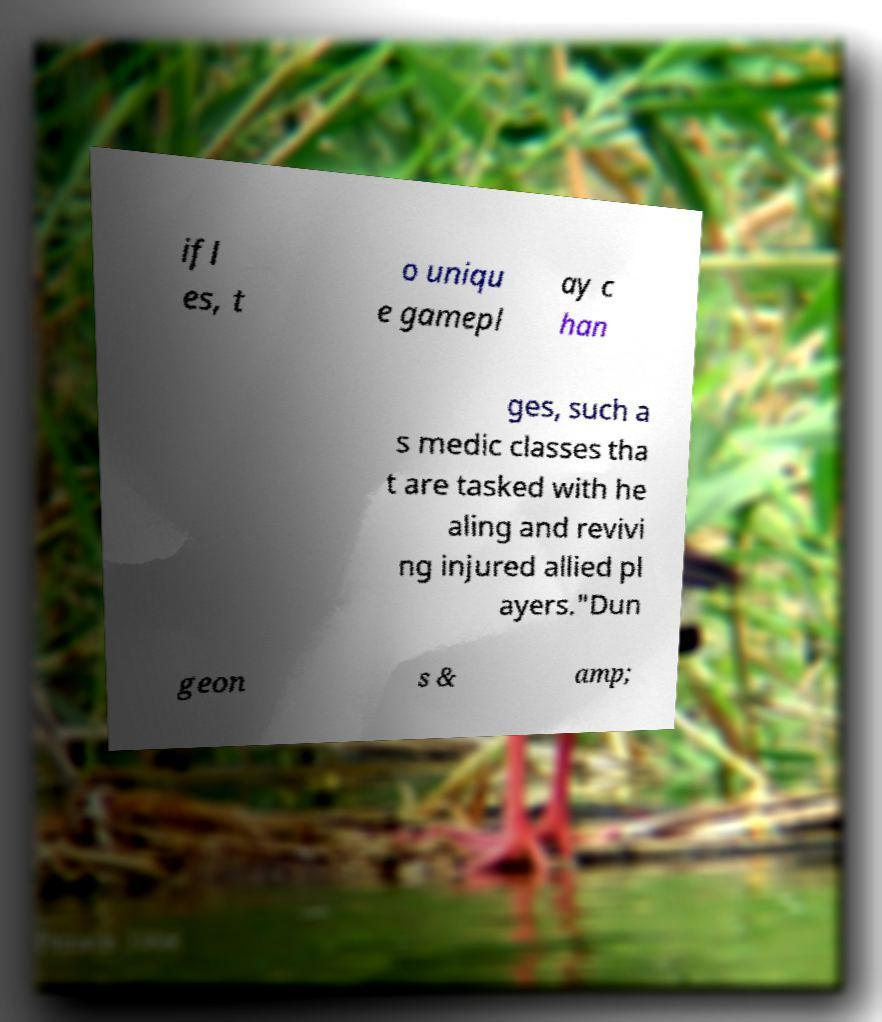Can you read and provide the text displayed in the image?This photo seems to have some interesting text. Can you extract and type it out for me? ifl es, t o uniqu e gamepl ay c han ges, such a s medic classes tha t are tasked with he aling and revivi ng injured allied pl ayers."Dun geon s & amp; 